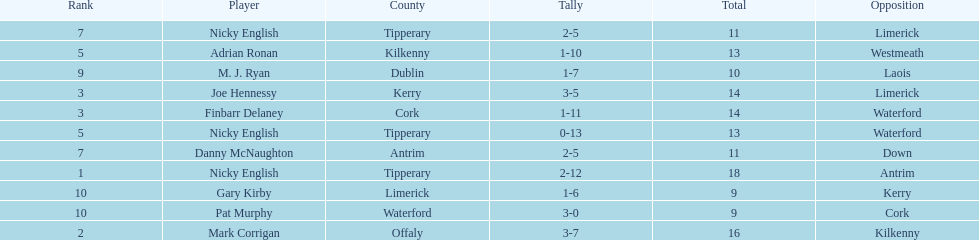What player got 10 total points in their game? M. J. Ryan. 